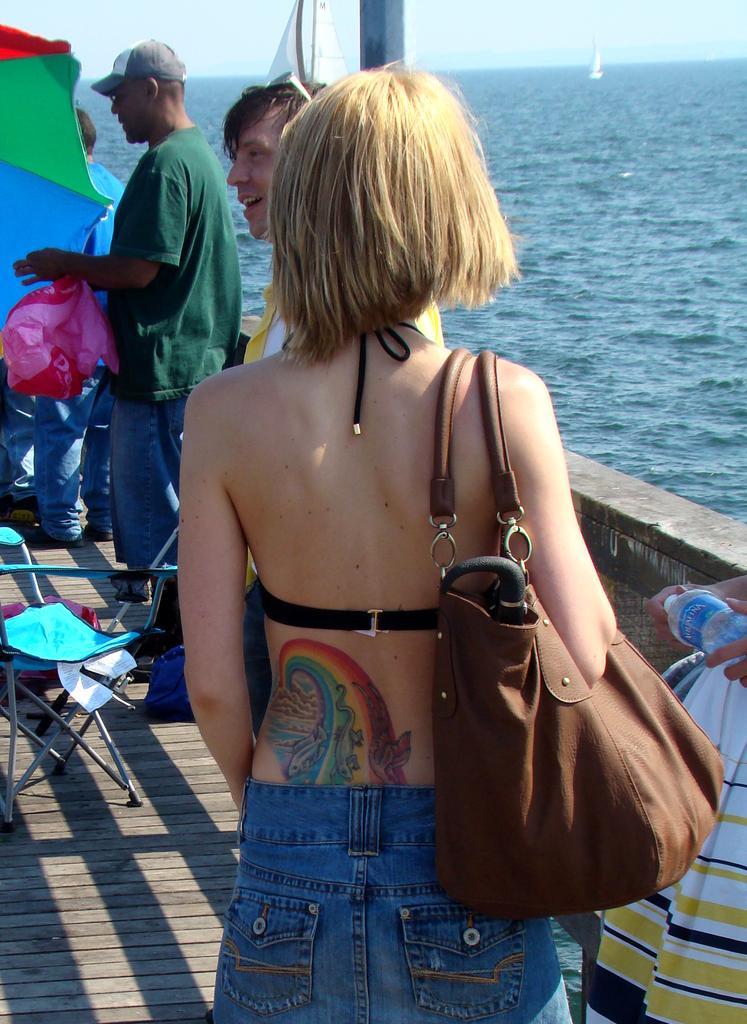Please provide a concise description of this image. In this image i can see group of persons standing on the boat. At the right side of the image there is water. 